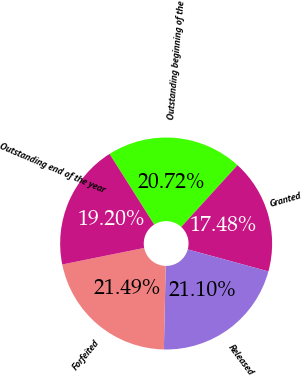<chart> <loc_0><loc_0><loc_500><loc_500><pie_chart><fcel>Outstanding beginning of the<fcel>Granted<fcel>Released<fcel>Forfeited<fcel>Outstanding end of the year<nl><fcel>20.72%<fcel>17.48%<fcel>21.1%<fcel>21.49%<fcel>19.2%<nl></chart> 